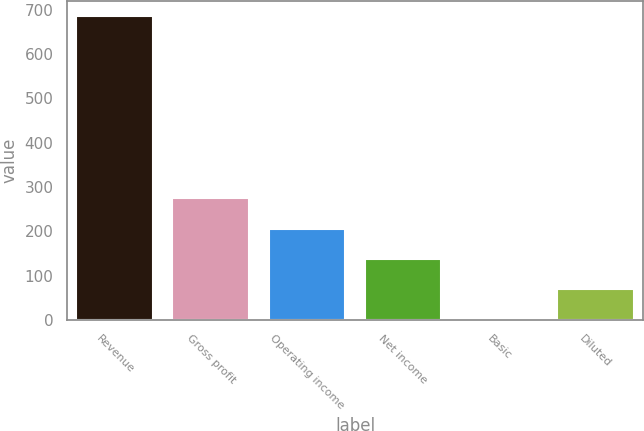Convert chart to OTSL. <chart><loc_0><loc_0><loc_500><loc_500><bar_chart><fcel>Revenue<fcel>Gross profit<fcel>Operating income<fcel>Net income<fcel>Basic<fcel>Diluted<nl><fcel>686<fcel>274.58<fcel>206.01<fcel>137.44<fcel>0.3<fcel>68.87<nl></chart> 